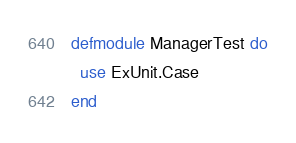Convert code to text. <code><loc_0><loc_0><loc_500><loc_500><_Elixir_>defmodule ManagerTest do
  use ExUnit.Case
end
</code> 